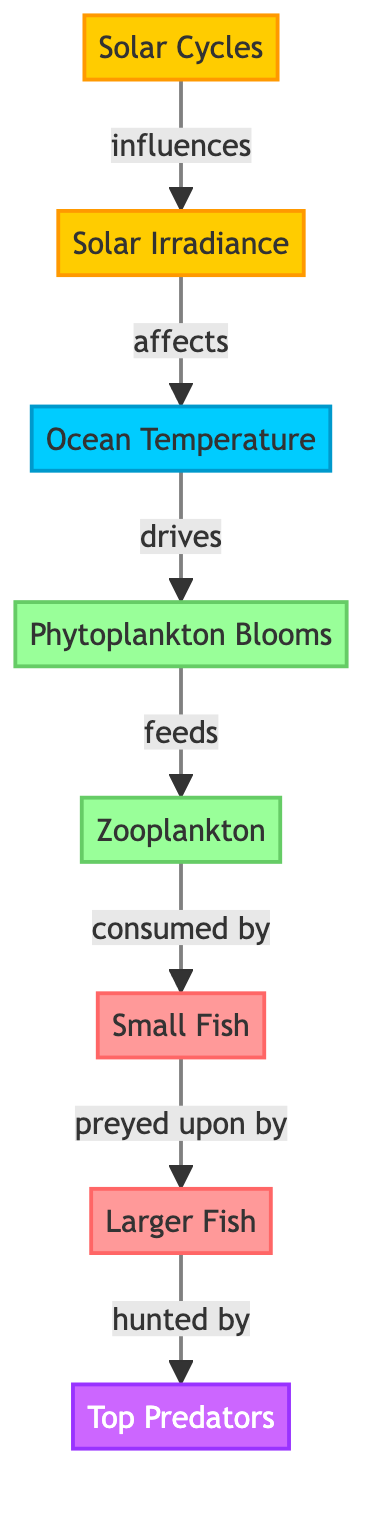What is the first node in the diagram? The first node in the diagram is 'Solar Cycles', which is the starting point of the flow illustrating various influences and effects in the food chain.
Answer: Solar Cycles How many nodes are in the diagram? By counting each unique node within the flowchart, there are a total of eight distinct nodes present, including 'Solar Cycles', 'Solar Irradiance', 'Ocean Temperature', 'Phytoplankton Blooms', 'Zooplankton', 'Small Fish', 'Larger Fish', and 'Top Predators'.
Answer: 8 Which node is directly affected by ocean temperature? The 'Phytoplankton Blooms' node is directly affected by ocean temperature, as depicted by the flow indicating that ocean temperature drives phytoplankton blooms.
Answer: Phytoplankton Blooms What feeds on zooplankton? The node that feeds on zooplankton is 'Small Fish', based on the flow that shows zooplankton consumed by small fish.
Answer: Small Fish What is the relationship between solar cycles and solar irradiance? The relationship is that solar cycles influence solar irradiance, as shown by the directed flow from 'Solar Cycles' to 'Solar Irradiance'.
Answer: influences What is the last node in this food chain? The last node in the food chain is 'Top Predators', as it follows the chain from larger fish, indicating who preys upon them.
Answer: Top Predators How do larger fish relate to small fish in this diagram? Larger fish are predated upon by top predators, while they are directly related to small fish because the latter are consumed by larger fish, showing a predator-prey relationship.
Answer: preyed upon by If ocean temperature increases, which node is likely to be affected first? An increase in ocean temperature will likely affect the 'Phytoplankton Blooms' first, since the diagram explicitly states that ocean temperature drives phytoplankton blooms.
Answer: Phytoplankton Blooms What is the flow direction from solar irradiance to ocean temperature? The flow direction from solar irradiance to ocean temperature indicates that solar irradiance affects ocean temperature, illustrating a cause-and-effect relationship in the diagram.
Answer: affects 